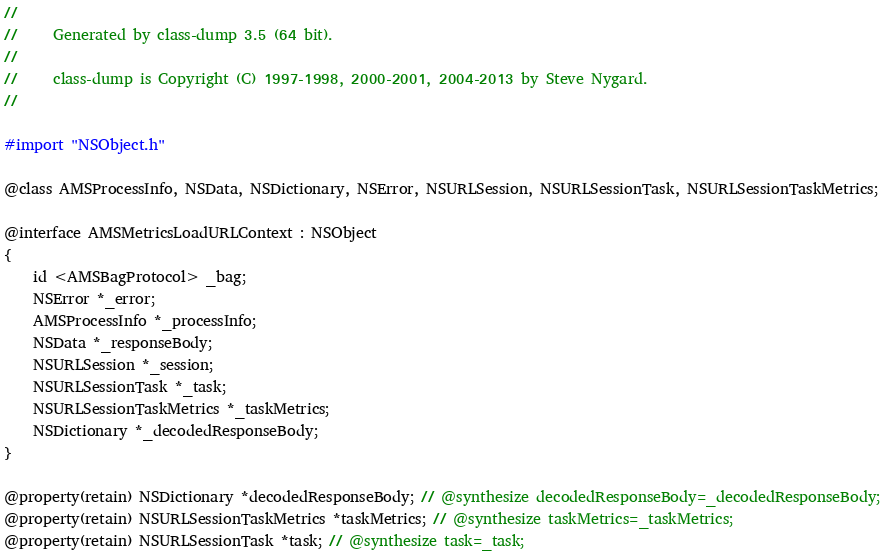<code> <loc_0><loc_0><loc_500><loc_500><_C_>//
//     Generated by class-dump 3.5 (64 bit).
//
//     class-dump is Copyright (C) 1997-1998, 2000-2001, 2004-2013 by Steve Nygard.
//

#import "NSObject.h"

@class AMSProcessInfo, NSData, NSDictionary, NSError, NSURLSession, NSURLSessionTask, NSURLSessionTaskMetrics;

@interface AMSMetricsLoadURLContext : NSObject
{
    id <AMSBagProtocol> _bag;
    NSError *_error;
    AMSProcessInfo *_processInfo;
    NSData *_responseBody;
    NSURLSession *_session;
    NSURLSessionTask *_task;
    NSURLSessionTaskMetrics *_taskMetrics;
    NSDictionary *_decodedResponseBody;
}

@property(retain) NSDictionary *decodedResponseBody; // @synthesize decodedResponseBody=_decodedResponseBody;
@property(retain) NSURLSessionTaskMetrics *taskMetrics; // @synthesize taskMetrics=_taskMetrics;
@property(retain) NSURLSessionTask *task; // @synthesize task=_task;</code> 